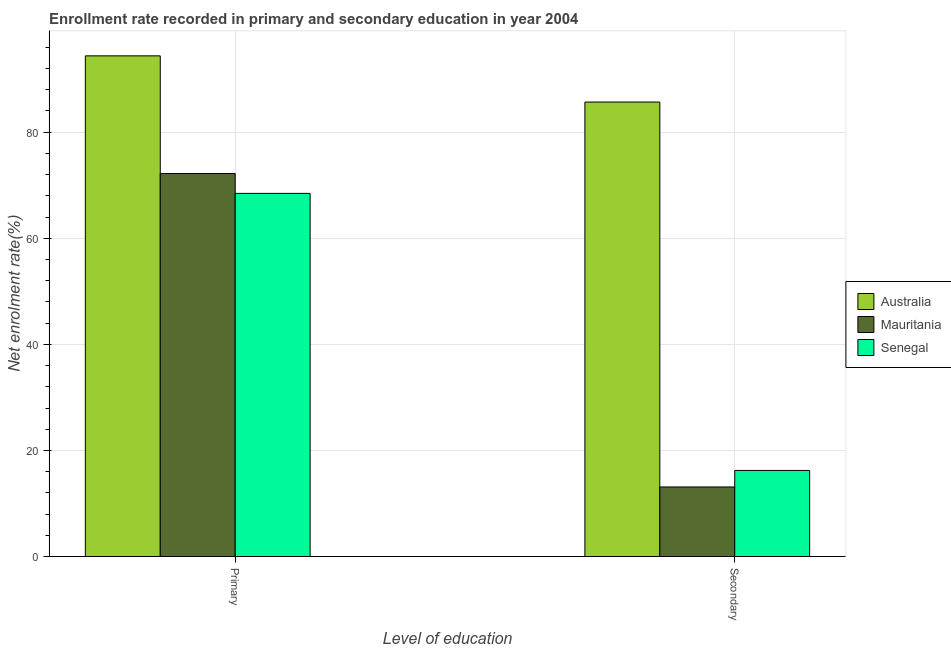How many different coloured bars are there?
Your response must be concise. 3. How many groups of bars are there?
Provide a short and direct response. 2. Are the number of bars per tick equal to the number of legend labels?
Provide a short and direct response. Yes. Are the number of bars on each tick of the X-axis equal?
Provide a short and direct response. Yes. How many bars are there on the 2nd tick from the left?
Offer a terse response. 3. How many bars are there on the 2nd tick from the right?
Provide a short and direct response. 3. What is the label of the 2nd group of bars from the left?
Give a very brief answer. Secondary. What is the enrollment rate in primary education in Mauritania?
Your answer should be very brief. 72.2. Across all countries, what is the maximum enrollment rate in secondary education?
Your response must be concise. 85.68. Across all countries, what is the minimum enrollment rate in secondary education?
Keep it short and to the point. 13.11. In which country was the enrollment rate in primary education maximum?
Your response must be concise. Australia. In which country was the enrollment rate in primary education minimum?
Offer a very short reply. Senegal. What is the total enrollment rate in primary education in the graph?
Your answer should be compact. 235.05. What is the difference between the enrollment rate in primary education in Australia and that in Mauritania?
Make the answer very short. 22.19. What is the difference between the enrollment rate in secondary education in Australia and the enrollment rate in primary education in Senegal?
Give a very brief answer. 17.22. What is the average enrollment rate in primary education per country?
Keep it short and to the point. 78.35. What is the difference between the enrollment rate in primary education and enrollment rate in secondary education in Australia?
Make the answer very short. 8.71. In how many countries, is the enrollment rate in secondary education greater than 88 %?
Make the answer very short. 0. What is the ratio of the enrollment rate in primary education in Australia to that in Senegal?
Provide a short and direct response. 1.38. In how many countries, is the enrollment rate in secondary education greater than the average enrollment rate in secondary education taken over all countries?
Your answer should be compact. 1. What does the 1st bar from the left in Secondary represents?
Give a very brief answer. Australia. Are all the bars in the graph horizontal?
Offer a terse response. No. How many countries are there in the graph?
Your response must be concise. 3. What is the difference between two consecutive major ticks on the Y-axis?
Give a very brief answer. 20. Are the values on the major ticks of Y-axis written in scientific E-notation?
Keep it short and to the point. No. Where does the legend appear in the graph?
Offer a very short reply. Center right. How many legend labels are there?
Offer a terse response. 3. What is the title of the graph?
Provide a short and direct response. Enrollment rate recorded in primary and secondary education in year 2004. What is the label or title of the X-axis?
Offer a terse response. Level of education. What is the label or title of the Y-axis?
Provide a short and direct response. Net enrolment rate(%). What is the Net enrolment rate(%) in Australia in Primary?
Give a very brief answer. 94.39. What is the Net enrolment rate(%) of Mauritania in Primary?
Offer a terse response. 72.2. What is the Net enrolment rate(%) in Senegal in Primary?
Your response must be concise. 68.46. What is the Net enrolment rate(%) of Australia in Secondary?
Your answer should be compact. 85.68. What is the Net enrolment rate(%) in Mauritania in Secondary?
Offer a very short reply. 13.11. What is the Net enrolment rate(%) of Senegal in Secondary?
Provide a succinct answer. 16.23. Across all Level of education, what is the maximum Net enrolment rate(%) of Australia?
Ensure brevity in your answer.  94.39. Across all Level of education, what is the maximum Net enrolment rate(%) in Mauritania?
Provide a short and direct response. 72.2. Across all Level of education, what is the maximum Net enrolment rate(%) of Senegal?
Provide a succinct answer. 68.46. Across all Level of education, what is the minimum Net enrolment rate(%) of Australia?
Keep it short and to the point. 85.68. Across all Level of education, what is the minimum Net enrolment rate(%) in Mauritania?
Give a very brief answer. 13.11. Across all Level of education, what is the minimum Net enrolment rate(%) of Senegal?
Offer a terse response. 16.23. What is the total Net enrolment rate(%) of Australia in the graph?
Your answer should be very brief. 180.07. What is the total Net enrolment rate(%) in Mauritania in the graph?
Keep it short and to the point. 85.31. What is the total Net enrolment rate(%) of Senegal in the graph?
Your answer should be very brief. 84.69. What is the difference between the Net enrolment rate(%) of Australia in Primary and that in Secondary?
Keep it short and to the point. 8.71. What is the difference between the Net enrolment rate(%) of Mauritania in Primary and that in Secondary?
Offer a very short reply. 59.09. What is the difference between the Net enrolment rate(%) of Senegal in Primary and that in Secondary?
Your response must be concise. 52.23. What is the difference between the Net enrolment rate(%) in Australia in Primary and the Net enrolment rate(%) in Mauritania in Secondary?
Keep it short and to the point. 81.28. What is the difference between the Net enrolment rate(%) of Australia in Primary and the Net enrolment rate(%) of Senegal in Secondary?
Offer a terse response. 78.16. What is the difference between the Net enrolment rate(%) in Mauritania in Primary and the Net enrolment rate(%) in Senegal in Secondary?
Offer a terse response. 55.97. What is the average Net enrolment rate(%) in Australia per Level of education?
Offer a very short reply. 90.03. What is the average Net enrolment rate(%) of Mauritania per Level of education?
Give a very brief answer. 42.66. What is the average Net enrolment rate(%) of Senegal per Level of education?
Your answer should be very brief. 42.35. What is the difference between the Net enrolment rate(%) in Australia and Net enrolment rate(%) in Mauritania in Primary?
Your answer should be compact. 22.19. What is the difference between the Net enrolment rate(%) of Australia and Net enrolment rate(%) of Senegal in Primary?
Offer a very short reply. 25.93. What is the difference between the Net enrolment rate(%) in Mauritania and Net enrolment rate(%) in Senegal in Primary?
Offer a very short reply. 3.74. What is the difference between the Net enrolment rate(%) of Australia and Net enrolment rate(%) of Mauritania in Secondary?
Offer a terse response. 72.57. What is the difference between the Net enrolment rate(%) in Australia and Net enrolment rate(%) in Senegal in Secondary?
Offer a terse response. 69.45. What is the difference between the Net enrolment rate(%) in Mauritania and Net enrolment rate(%) in Senegal in Secondary?
Offer a very short reply. -3.12. What is the ratio of the Net enrolment rate(%) in Australia in Primary to that in Secondary?
Offer a very short reply. 1.1. What is the ratio of the Net enrolment rate(%) of Mauritania in Primary to that in Secondary?
Your response must be concise. 5.51. What is the ratio of the Net enrolment rate(%) of Senegal in Primary to that in Secondary?
Provide a succinct answer. 4.22. What is the difference between the highest and the second highest Net enrolment rate(%) of Australia?
Your answer should be compact. 8.71. What is the difference between the highest and the second highest Net enrolment rate(%) in Mauritania?
Offer a terse response. 59.09. What is the difference between the highest and the second highest Net enrolment rate(%) in Senegal?
Provide a succinct answer. 52.23. What is the difference between the highest and the lowest Net enrolment rate(%) of Australia?
Provide a succinct answer. 8.71. What is the difference between the highest and the lowest Net enrolment rate(%) of Mauritania?
Your answer should be very brief. 59.09. What is the difference between the highest and the lowest Net enrolment rate(%) in Senegal?
Ensure brevity in your answer.  52.23. 